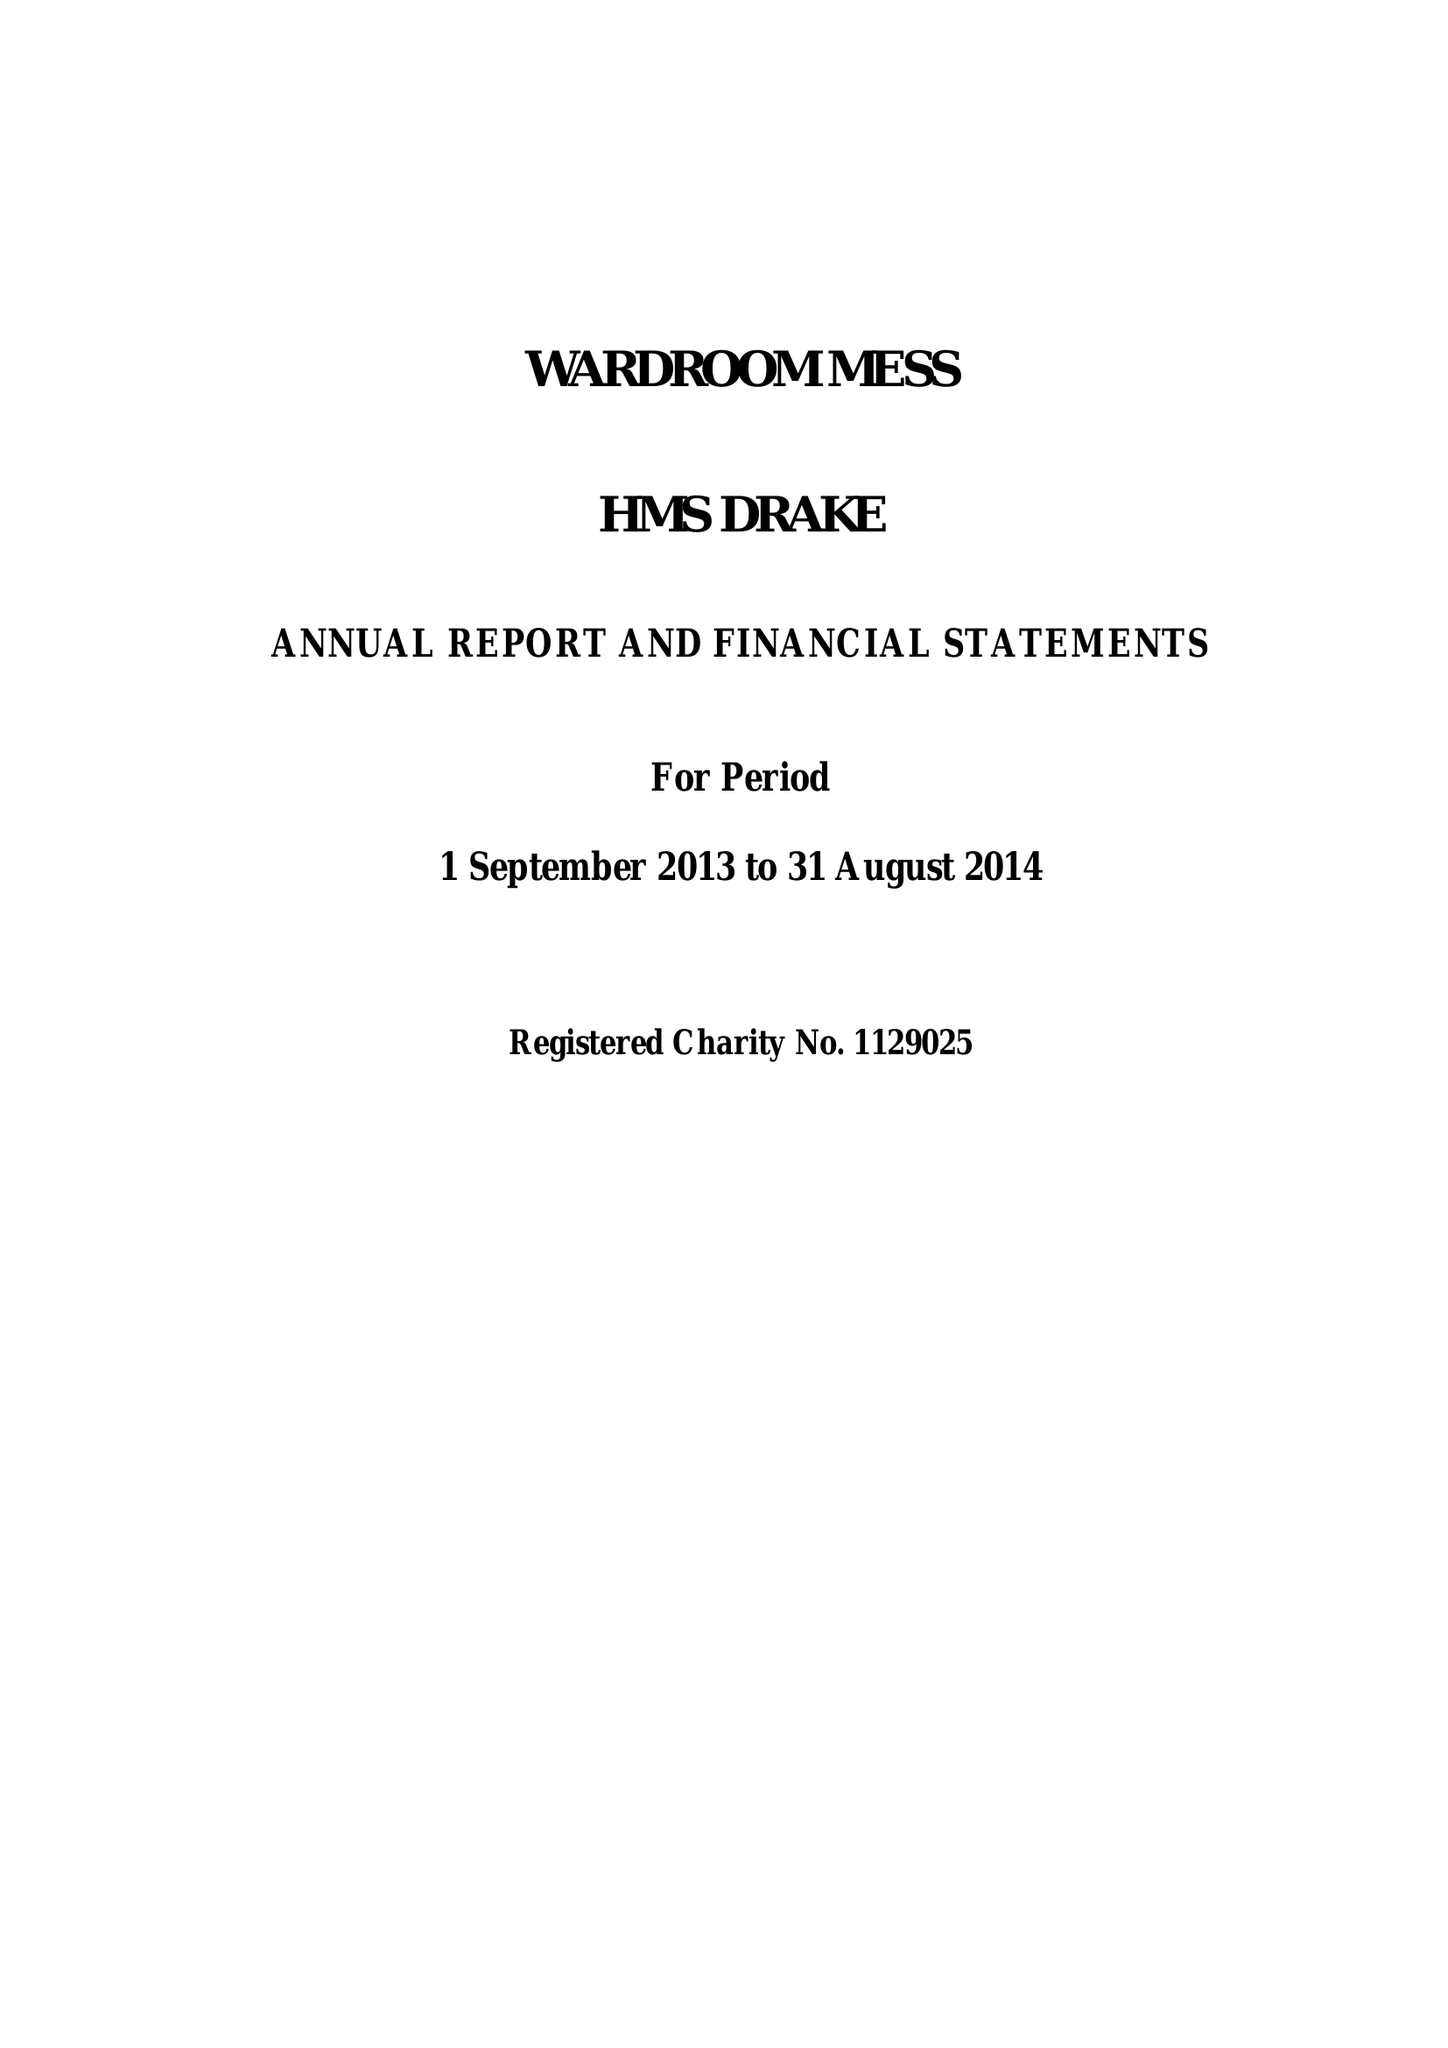What is the value for the address__street_line?
Answer the question using a single word or phrase. None 